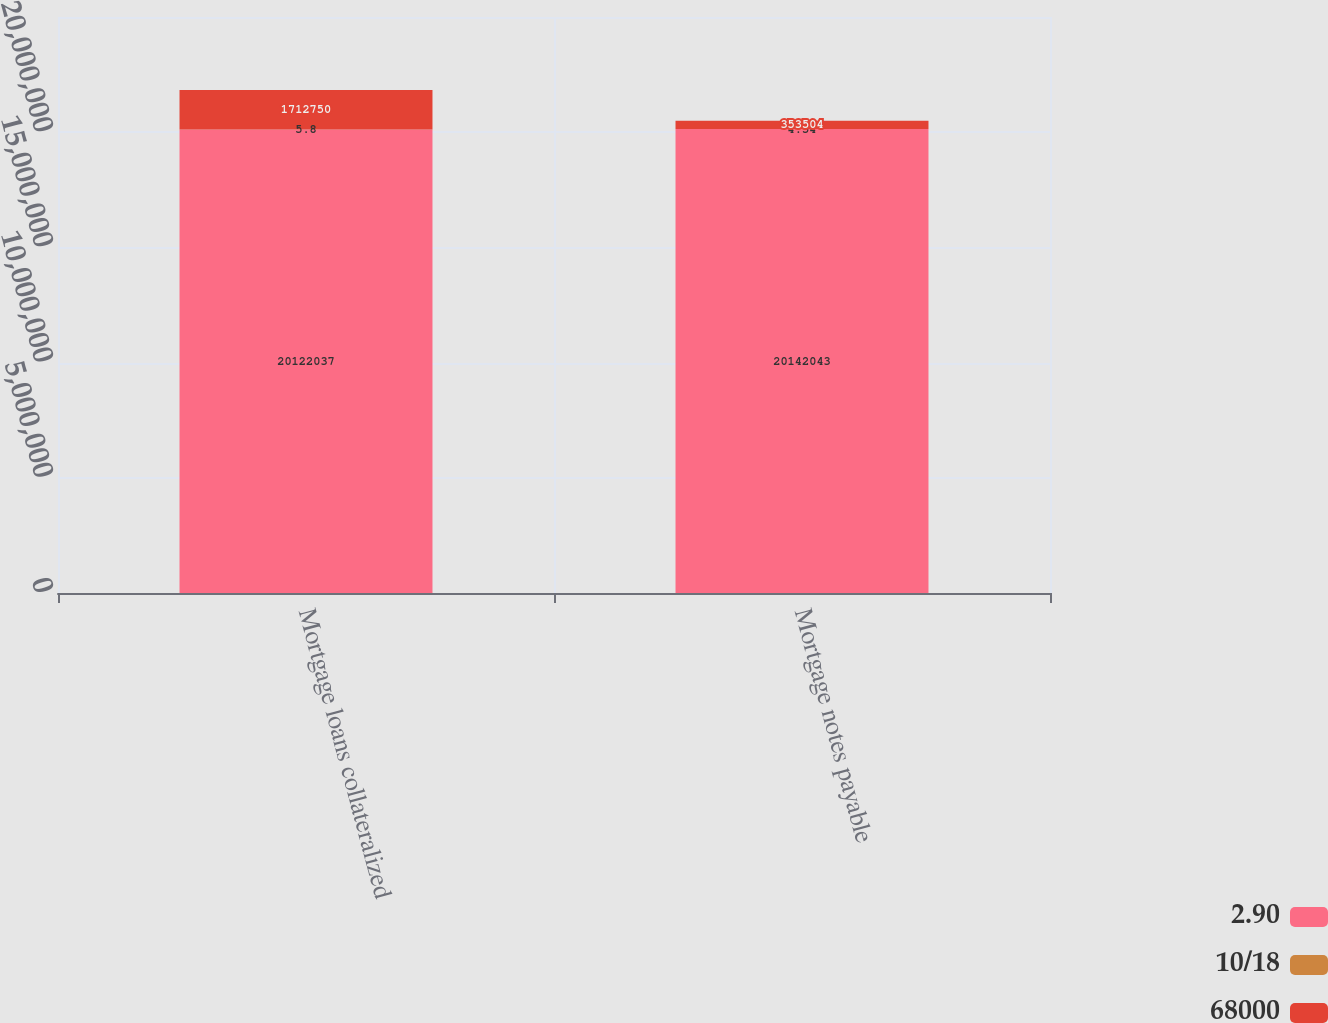Convert chart. <chart><loc_0><loc_0><loc_500><loc_500><stacked_bar_chart><ecel><fcel>Mortgage loans collateralized<fcel>Mortgage notes payable<nl><fcel>2.90<fcel>2.0122e+07<fcel>2.0142e+07<nl><fcel>10/18<fcel>5.8<fcel>4.54<nl><fcel>68000<fcel>1.71275e+06<fcel>353504<nl></chart> 